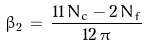Convert formula to latex. <formula><loc_0><loc_0><loc_500><loc_500>\beta _ { 2 } \, = \, \frac { 1 1 \, N _ { c } - 2 \, N _ { f } } { 1 2 \, \pi }</formula> 